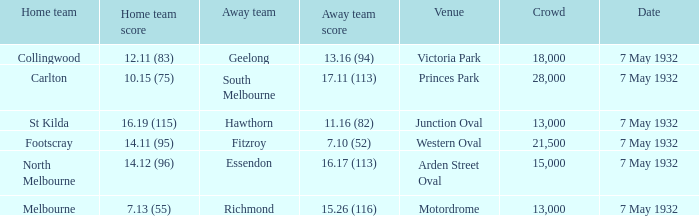12 (96)? 15000.0. 